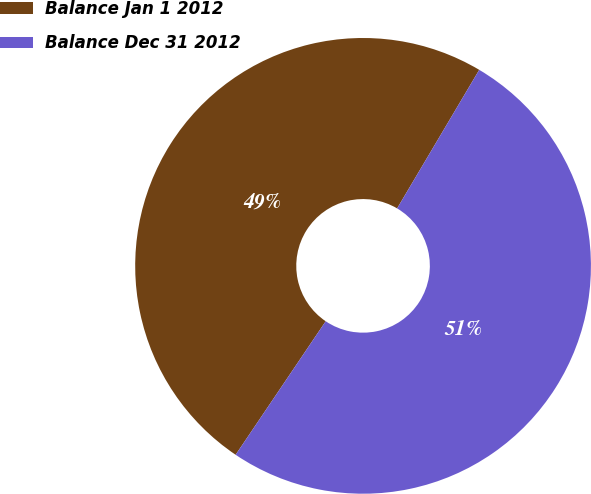Convert chart to OTSL. <chart><loc_0><loc_0><loc_500><loc_500><pie_chart><fcel>Balance Jan 1 2012<fcel>Balance Dec 31 2012<nl><fcel>49.07%<fcel>50.93%<nl></chart> 